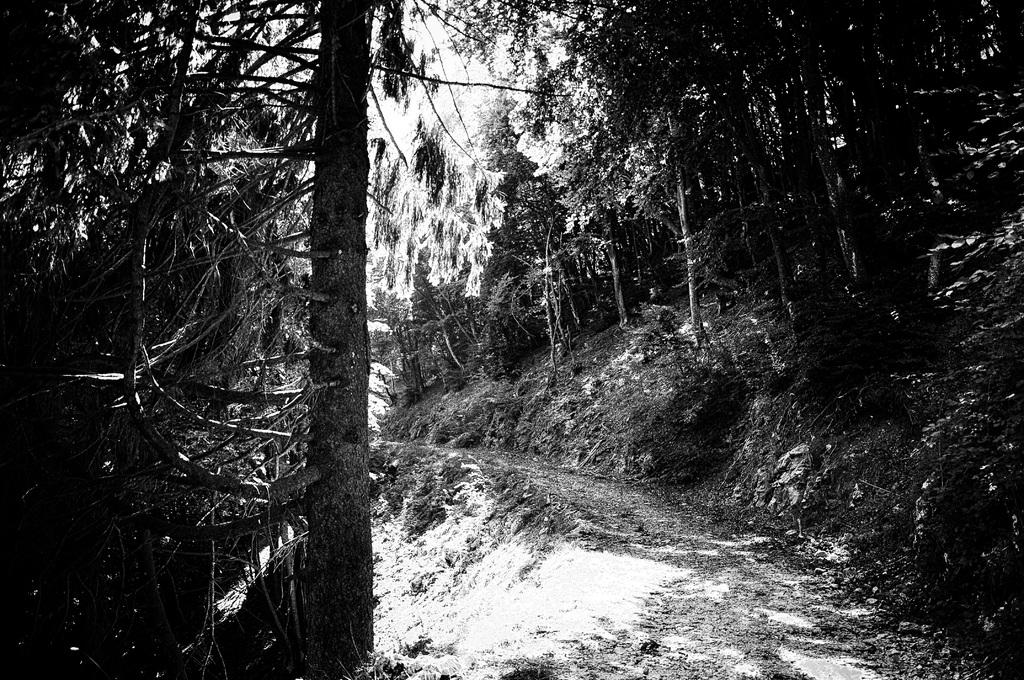What is the color scheme of the image? The image is black and white. What type of vegetation can be seen in the image? There are plants and trees in the image. Where are the plants and trees located? The plants and trees are on land. How many boys are playing with the sponge in the image? There are no boys or sponge present in the image. What is the baby doing in the image? There is no baby present in the image. 